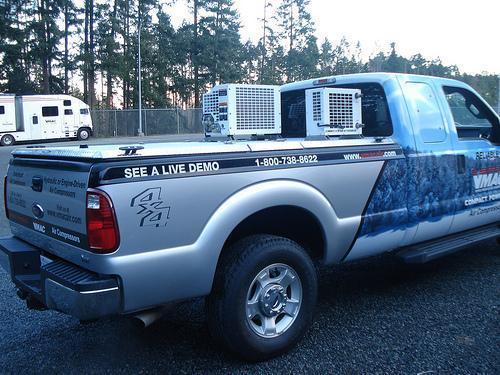How many trucks?
Give a very brief answer. 1. 